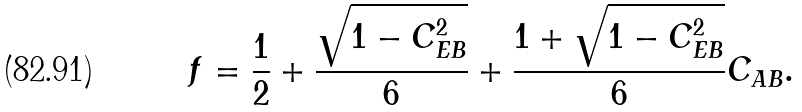<formula> <loc_0><loc_0><loc_500><loc_500>f = \frac { 1 } { 2 } + \frac { \sqrt { 1 - C _ { E B } ^ { 2 } } } { 6 } + \frac { 1 + \sqrt { 1 - C _ { E B } ^ { 2 } } } { 6 } C _ { A B } .</formula> 